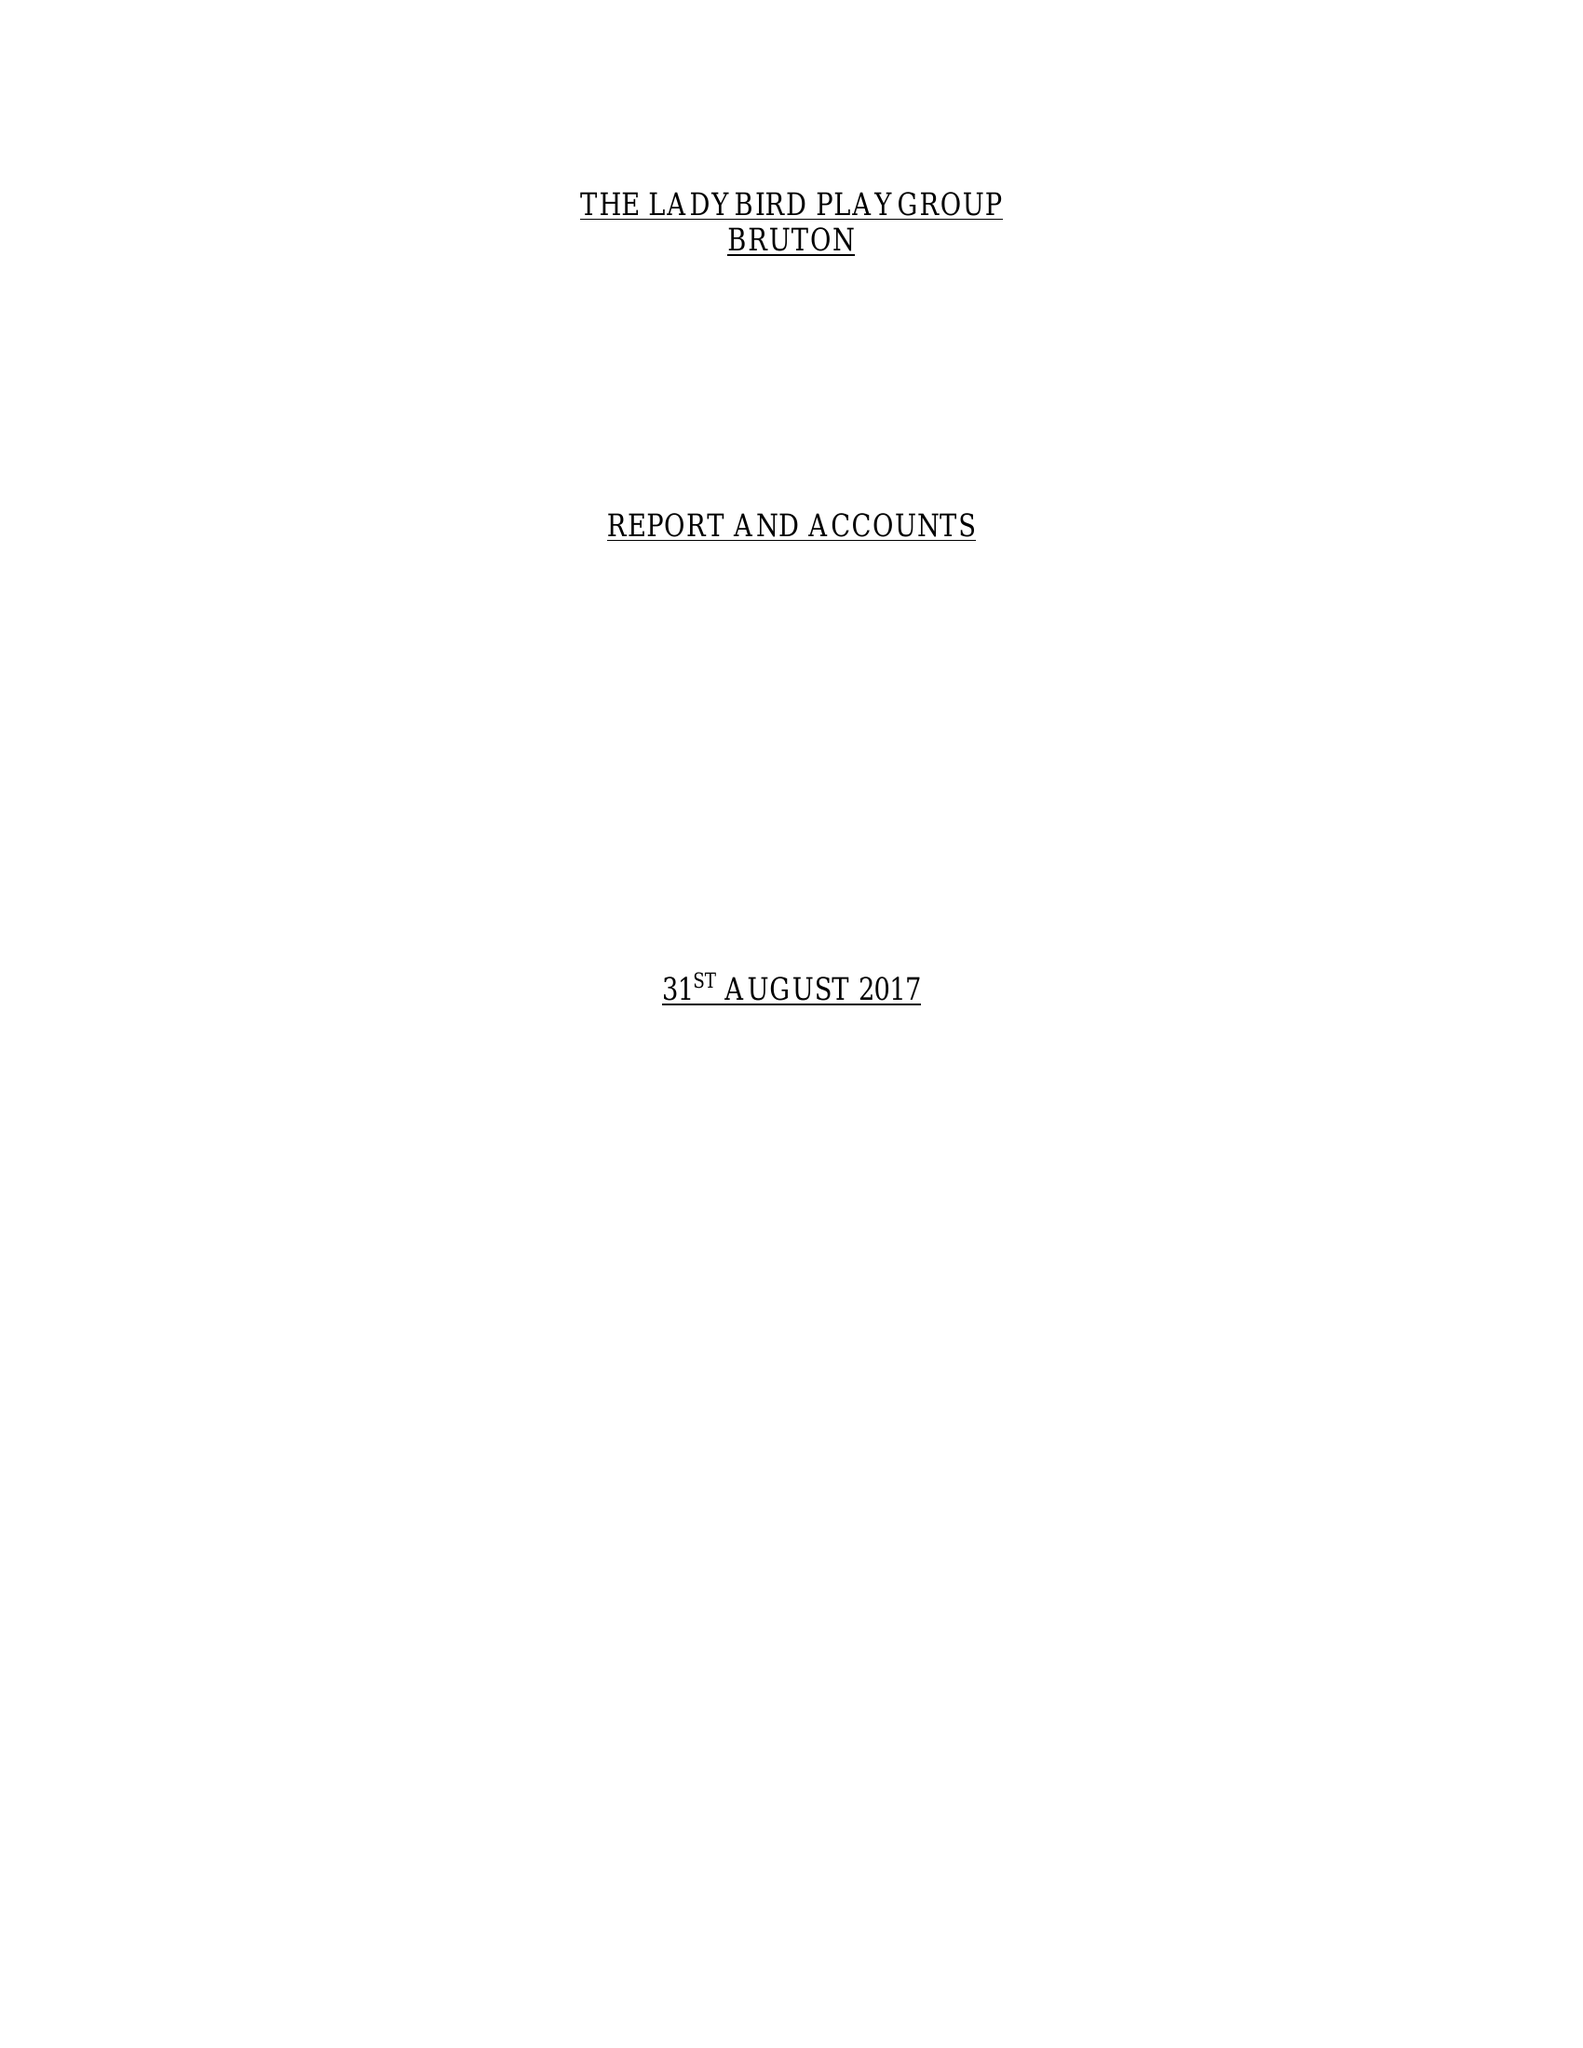What is the value for the address__post_town?
Answer the question using a single word or phrase. BRUTON 